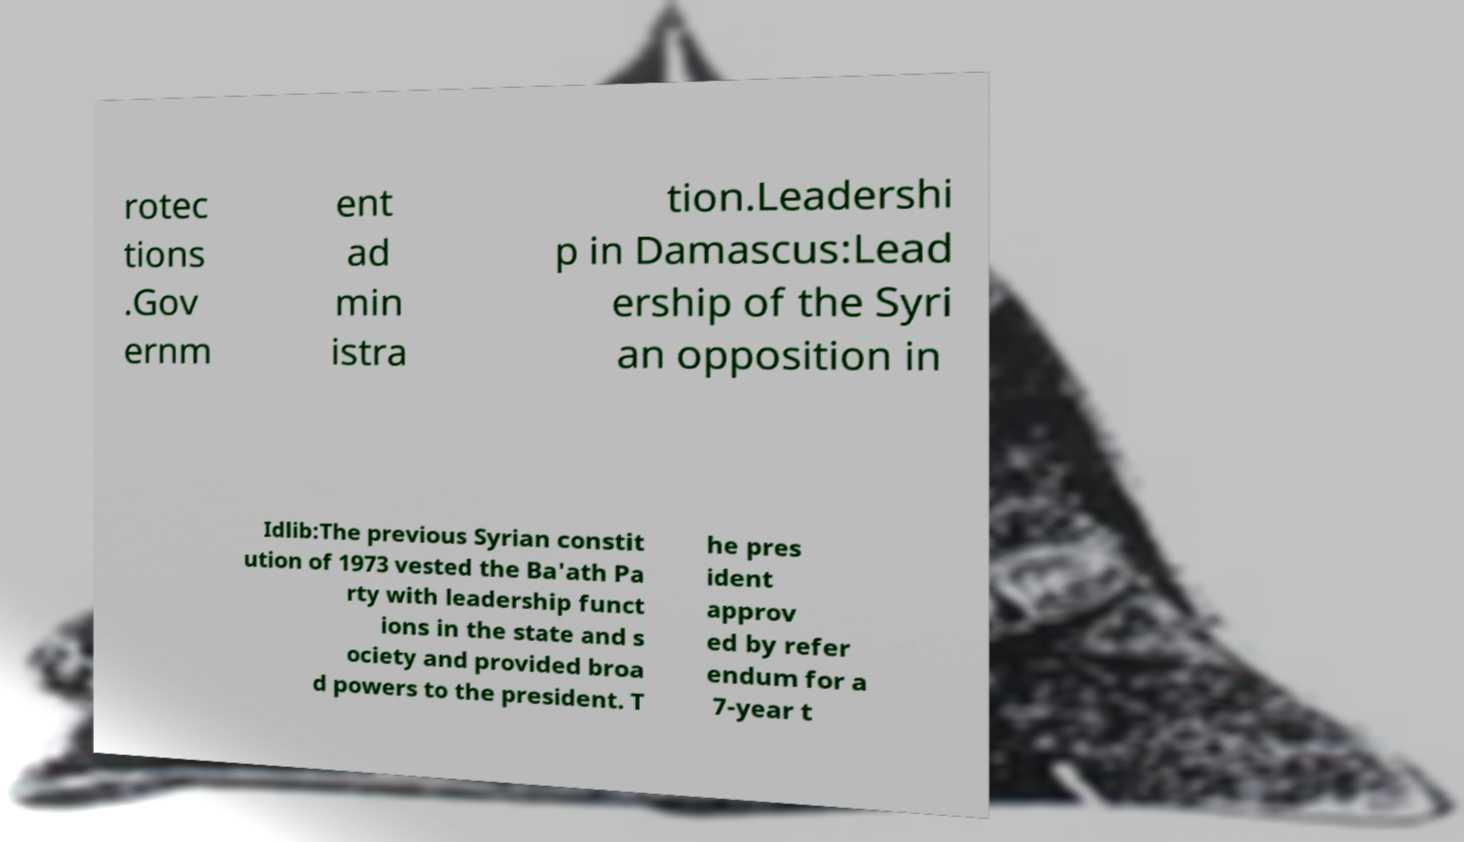I need the written content from this picture converted into text. Can you do that? rotec tions .Gov ernm ent ad min istra tion.Leadershi p in Damascus:Lead ership of the Syri an opposition in Idlib:The previous Syrian constit ution of 1973 vested the Ba'ath Pa rty with leadership funct ions in the state and s ociety and provided broa d powers to the president. T he pres ident approv ed by refer endum for a 7-year t 